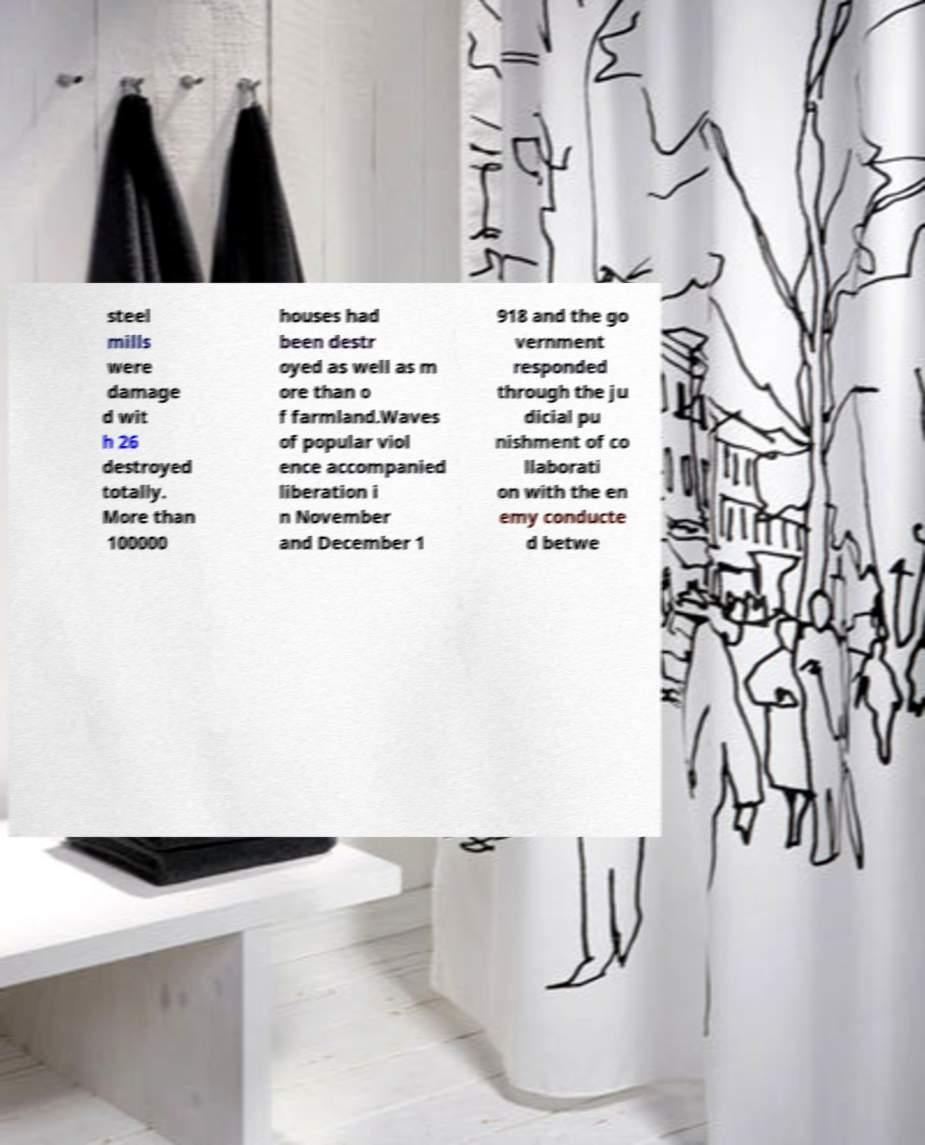Please read and relay the text visible in this image. What does it say? steel mills were damage d wit h 26 destroyed totally. More than 100000 houses had been destr oyed as well as m ore than o f farmland.Waves of popular viol ence accompanied liberation i n November and December 1 918 and the go vernment responded through the ju dicial pu nishment of co llaborati on with the en emy conducte d betwe 